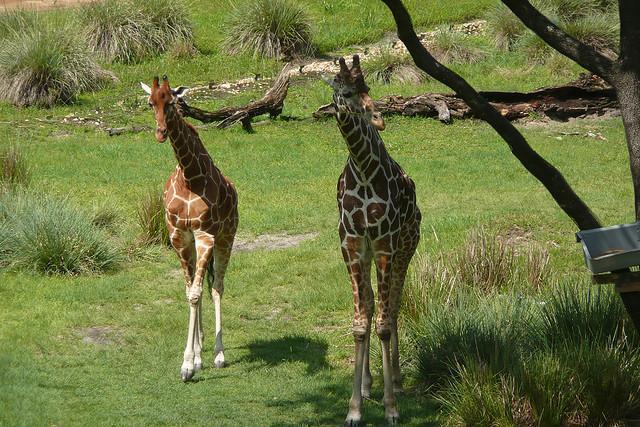How many giraffes can be seen?
Give a very brief answer. 2. How many benches are in front?
Give a very brief answer. 0. 